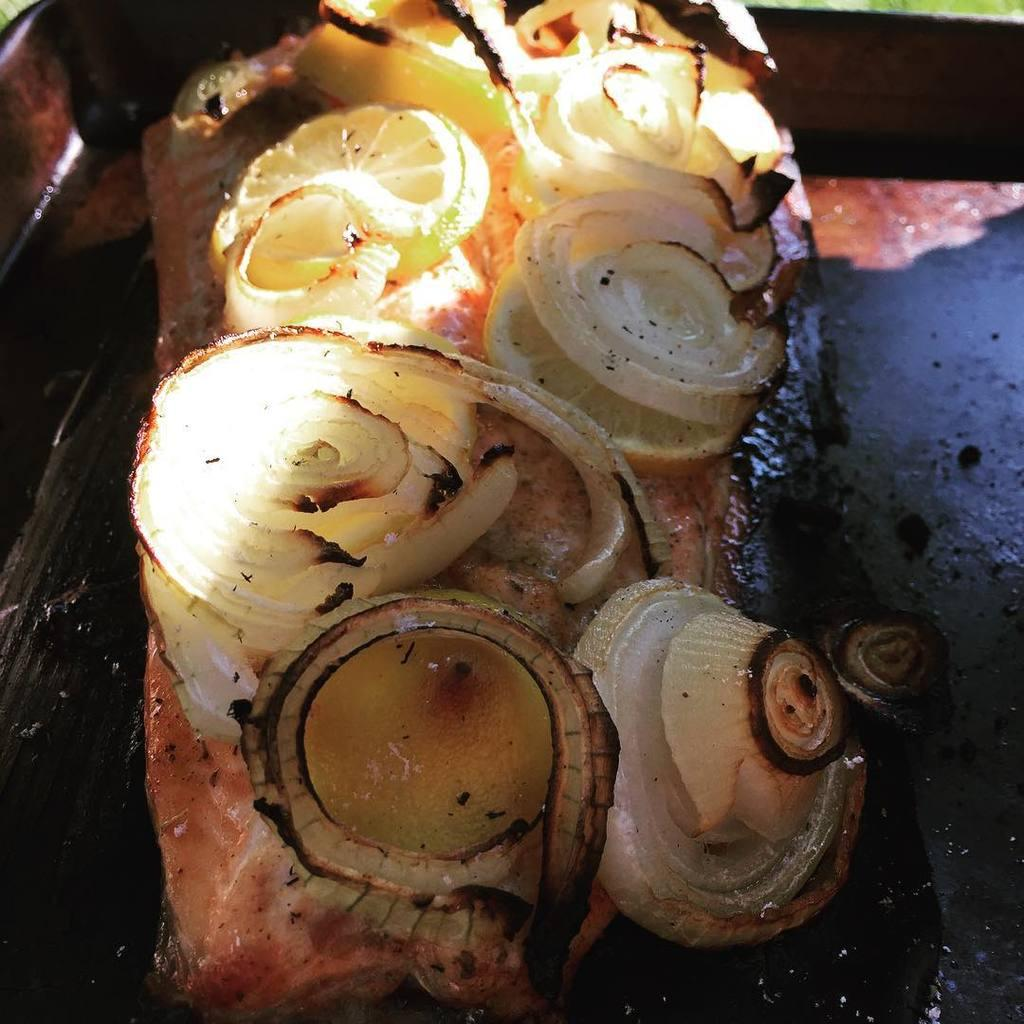What type of food item has the onion and lemon on it? The onion and lemon are on a food item, but the specific type of food item is not mentioned in the facts. What are the two main ingredients visible in the image? The two main ingredients visible in the image are pieces of onion and pieces of lemon. What color is the heart-shaped underwear in the image? There is no mention of heart-shaped underwear or any underwear in the image. The image only contains pieces of onion and lemon on a food item. 